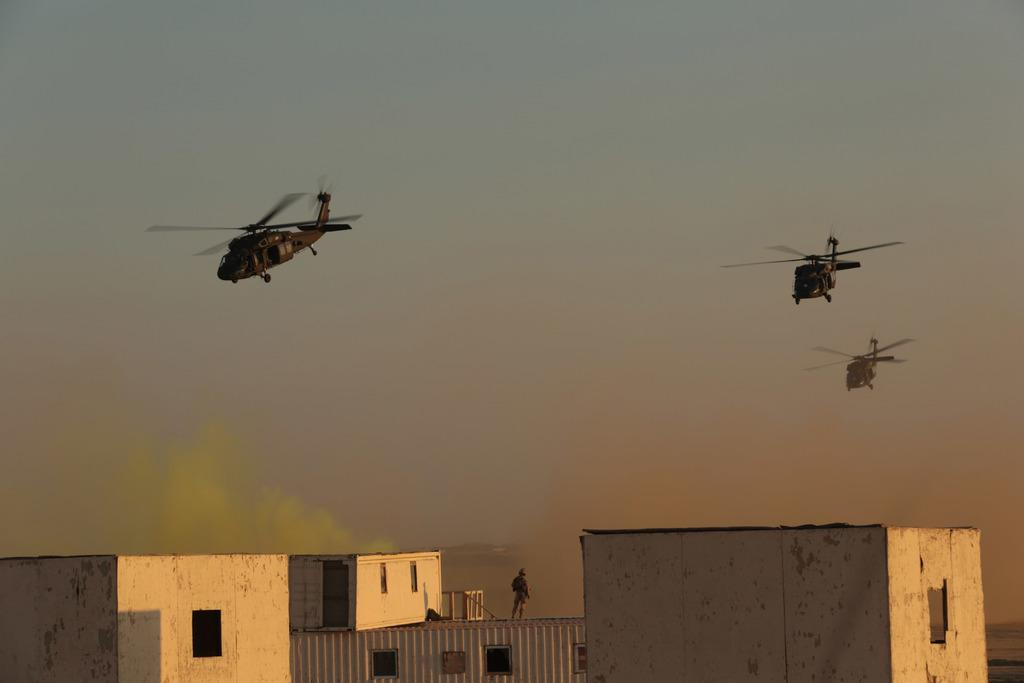What can be seen in the sky in the image? There are three helicopters in the sky. What is located at the bottom of the image? There are buildings at the bottom of the image. Is there any activity involving people in the image? Yes, there is a person standing on one of the buildings. What type of salt can be seen being transported by the train in the image? There is no train present in the image, so it is not possible to determine what type of salt might be transported. 